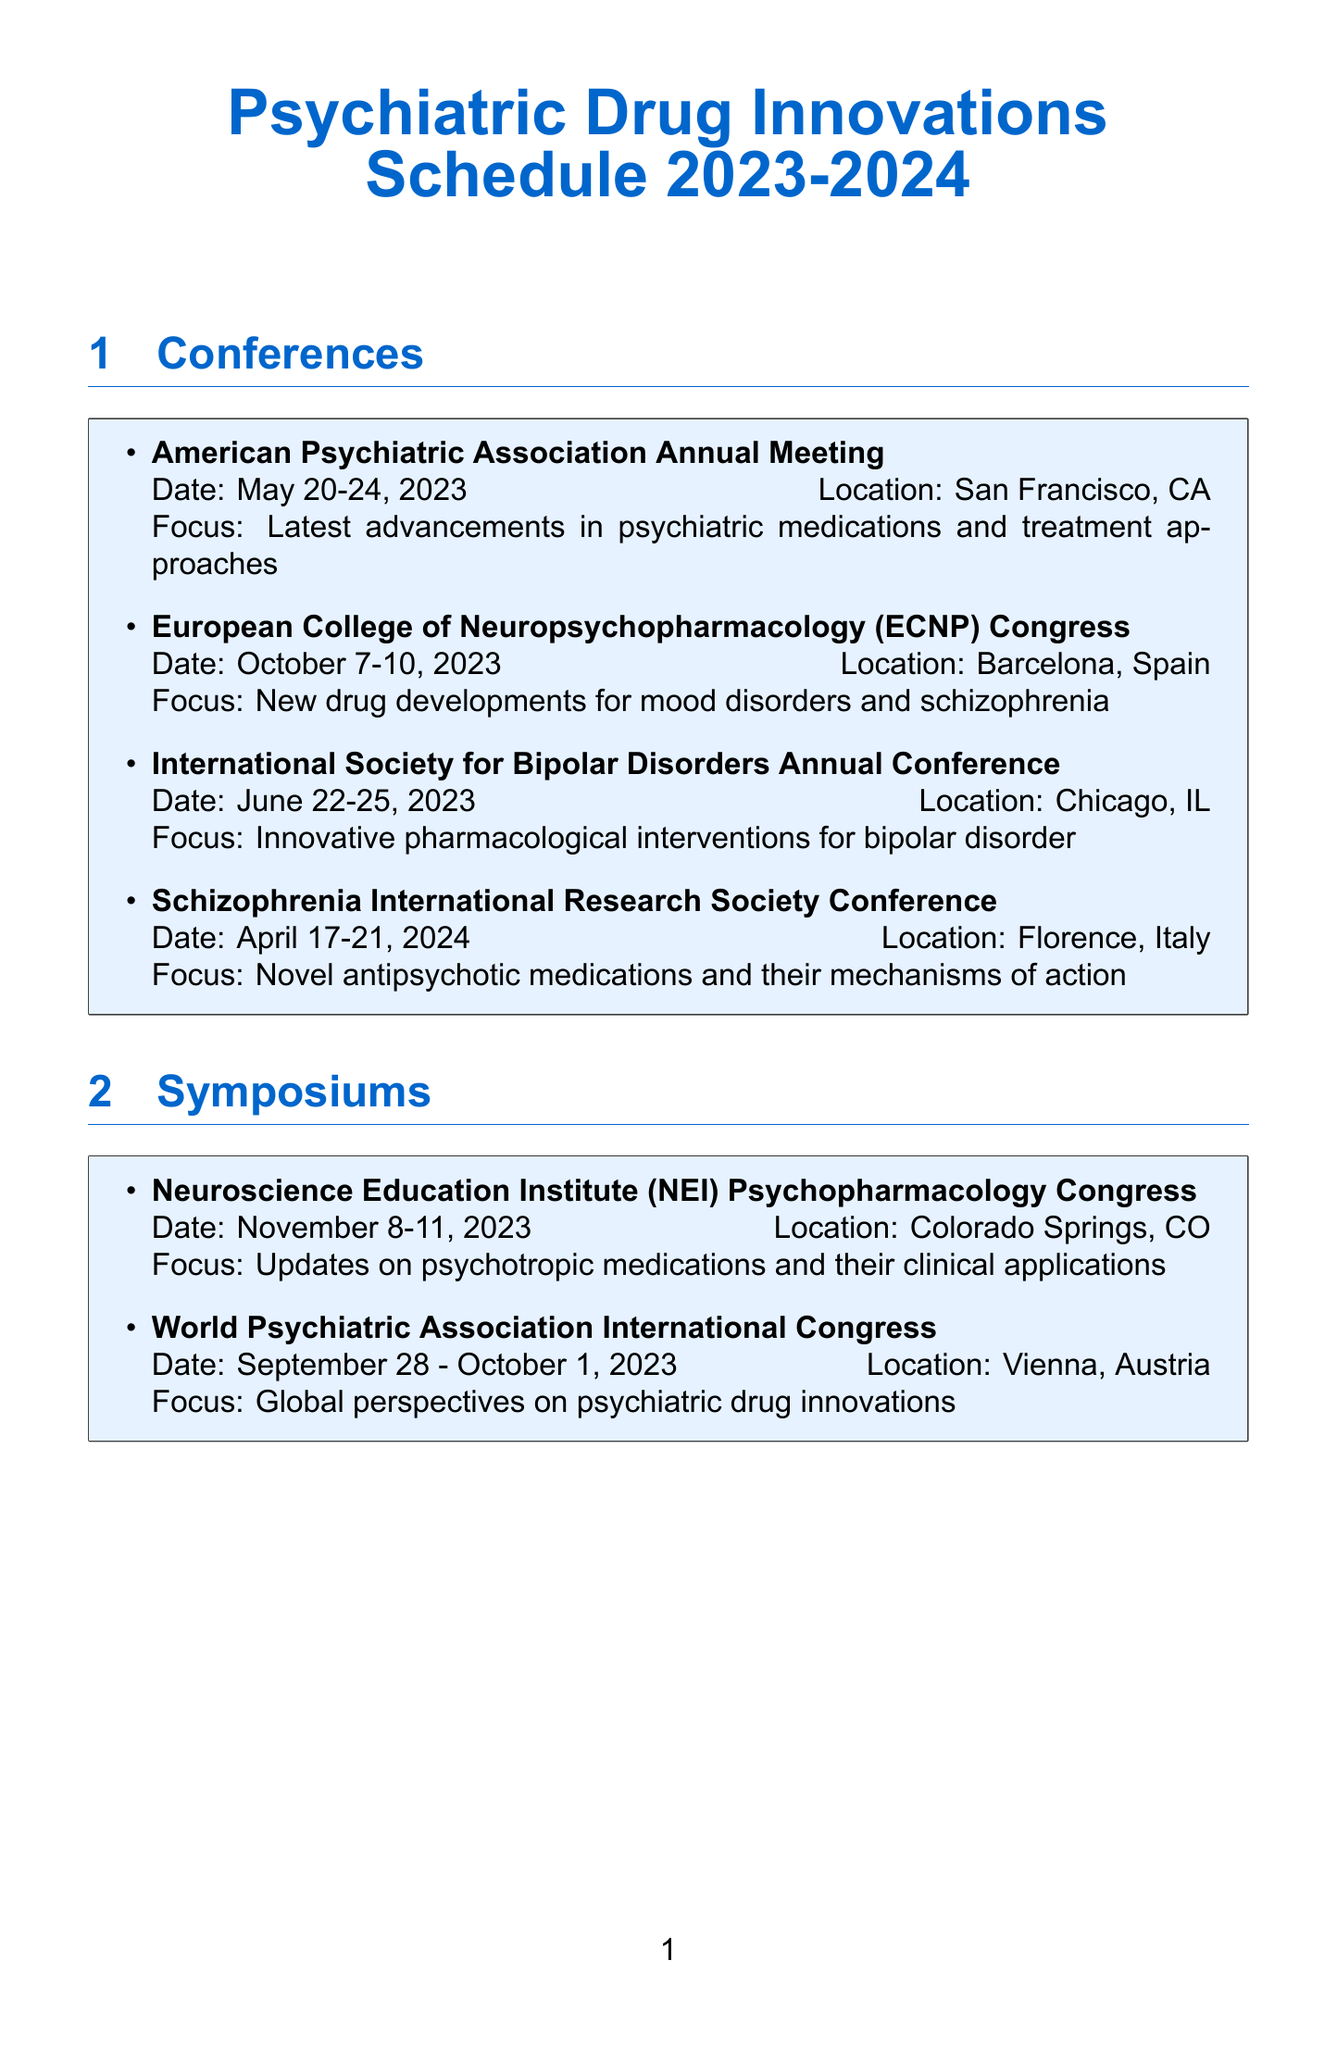What is the date of the American Psychiatric Association Annual Meeting? The date of the American Psychiatric Association Annual Meeting is provided in the document.
Answer: May 20-24, 2023 Where is the European College of Neuropsychopharmacology Congress held? The location of the European College of Neuropsychopharmacology Congress is mentioned in the document.
Answer: Barcelona, Spain Who is the presenter of the research update on pharmacogenomics? The document lists the presenters of various research updates, including pharmacogenomics.
Answer: Dr. Katharina Domschke What is the main focus of the Neuroscience Education Institute Psychopharmacology Congress? The focus of the congress is specified in the document.
Answer: Updates on psychotropic medications and their clinical applications Which conference takes place in April 2024? The document includes dates for several conferences, one of which is in April 2024.
Answer: Schizophrenia International Research Society Conference How many symposiums are listed in the document? The total number of symposiums is found by counting the entries in the symposium section of the document.
Answer: 2 What is the focus of the International Society for Bipolar Disorders Annual Conference? The focus is stated explicitly in the document.
Answer: Innovative pharmacological interventions for bipolar disorder Which company sponsors the Emerging Treatments in Mood Disorders Luncheon? The sponsor of the luncheon is mentioned in the networking events section of the document.
Answer: Lundbeck What location hosts the World Psychiatric Association International Congress? The document provides the location for the World Psychiatric Association International Congress.
Answer: Vienna, Austria 